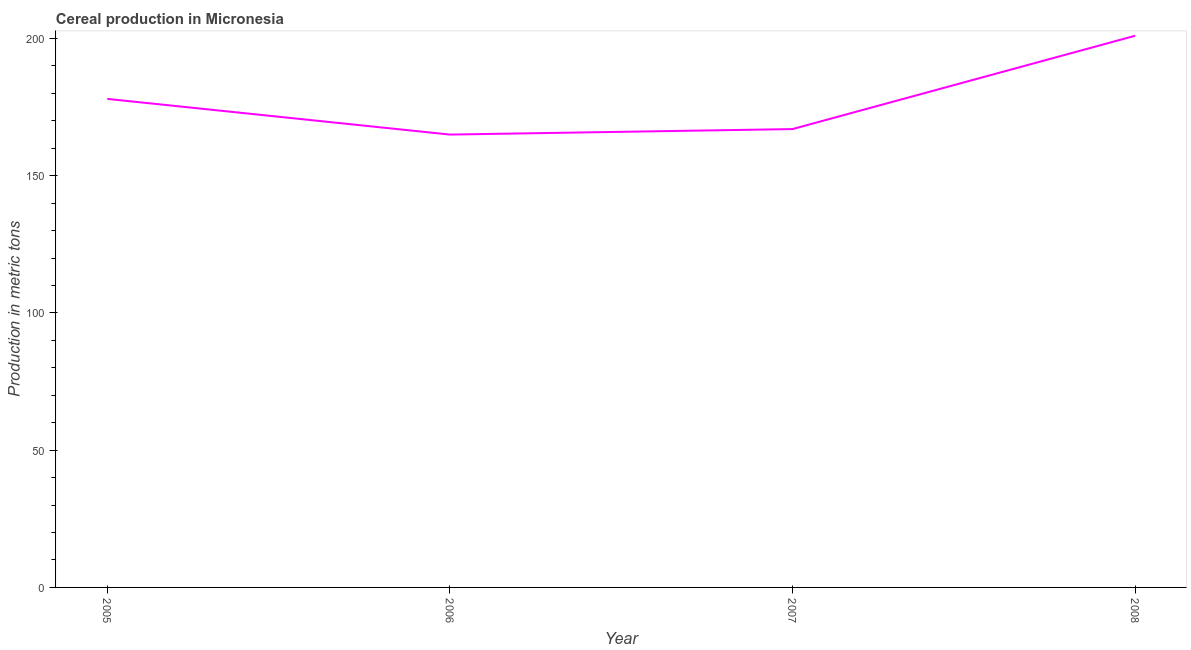What is the cereal production in 2006?
Ensure brevity in your answer.  165. Across all years, what is the maximum cereal production?
Give a very brief answer. 201. Across all years, what is the minimum cereal production?
Provide a short and direct response. 165. In which year was the cereal production maximum?
Your answer should be very brief. 2008. In which year was the cereal production minimum?
Offer a terse response. 2006. What is the sum of the cereal production?
Your answer should be compact. 711. What is the difference between the cereal production in 2005 and 2008?
Your answer should be compact. -23. What is the average cereal production per year?
Keep it short and to the point. 177.75. What is the median cereal production?
Keep it short and to the point. 172.5. In how many years, is the cereal production greater than 110 metric tons?
Provide a short and direct response. 4. Do a majority of the years between 2006 and 2005 (inclusive) have cereal production greater than 20 metric tons?
Your answer should be compact. No. What is the ratio of the cereal production in 2006 to that in 2007?
Give a very brief answer. 0.99. Is the cereal production in 2005 less than that in 2007?
Provide a short and direct response. No. Is the sum of the cereal production in 2005 and 2008 greater than the maximum cereal production across all years?
Your answer should be compact. Yes. What is the difference between the highest and the lowest cereal production?
Keep it short and to the point. 36. In how many years, is the cereal production greater than the average cereal production taken over all years?
Provide a short and direct response. 2. How many lines are there?
Ensure brevity in your answer.  1. How many years are there in the graph?
Make the answer very short. 4. What is the difference between two consecutive major ticks on the Y-axis?
Offer a very short reply. 50. Does the graph contain any zero values?
Offer a terse response. No. Does the graph contain grids?
Make the answer very short. No. What is the title of the graph?
Ensure brevity in your answer.  Cereal production in Micronesia. What is the label or title of the Y-axis?
Your answer should be very brief. Production in metric tons. What is the Production in metric tons in 2005?
Provide a succinct answer. 178. What is the Production in metric tons of 2006?
Offer a very short reply. 165. What is the Production in metric tons in 2007?
Provide a short and direct response. 167. What is the Production in metric tons of 2008?
Provide a succinct answer. 201. What is the difference between the Production in metric tons in 2005 and 2006?
Offer a terse response. 13. What is the difference between the Production in metric tons in 2006 and 2008?
Keep it short and to the point. -36. What is the difference between the Production in metric tons in 2007 and 2008?
Provide a short and direct response. -34. What is the ratio of the Production in metric tons in 2005 to that in 2006?
Offer a very short reply. 1.08. What is the ratio of the Production in metric tons in 2005 to that in 2007?
Your answer should be very brief. 1.07. What is the ratio of the Production in metric tons in 2005 to that in 2008?
Make the answer very short. 0.89. What is the ratio of the Production in metric tons in 2006 to that in 2007?
Offer a very short reply. 0.99. What is the ratio of the Production in metric tons in 2006 to that in 2008?
Keep it short and to the point. 0.82. What is the ratio of the Production in metric tons in 2007 to that in 2008?
Ensure brevity in your answer.  0.83. 